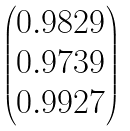<formula> <loc_0><loc_0><loc_500><loc_500>\begin{pmatrix} 0 . 9 8 2 9 \\ 0 . 9 7 3 9 \\ 0 . 9 9 2 7 \end{pmatrix}</formula> 